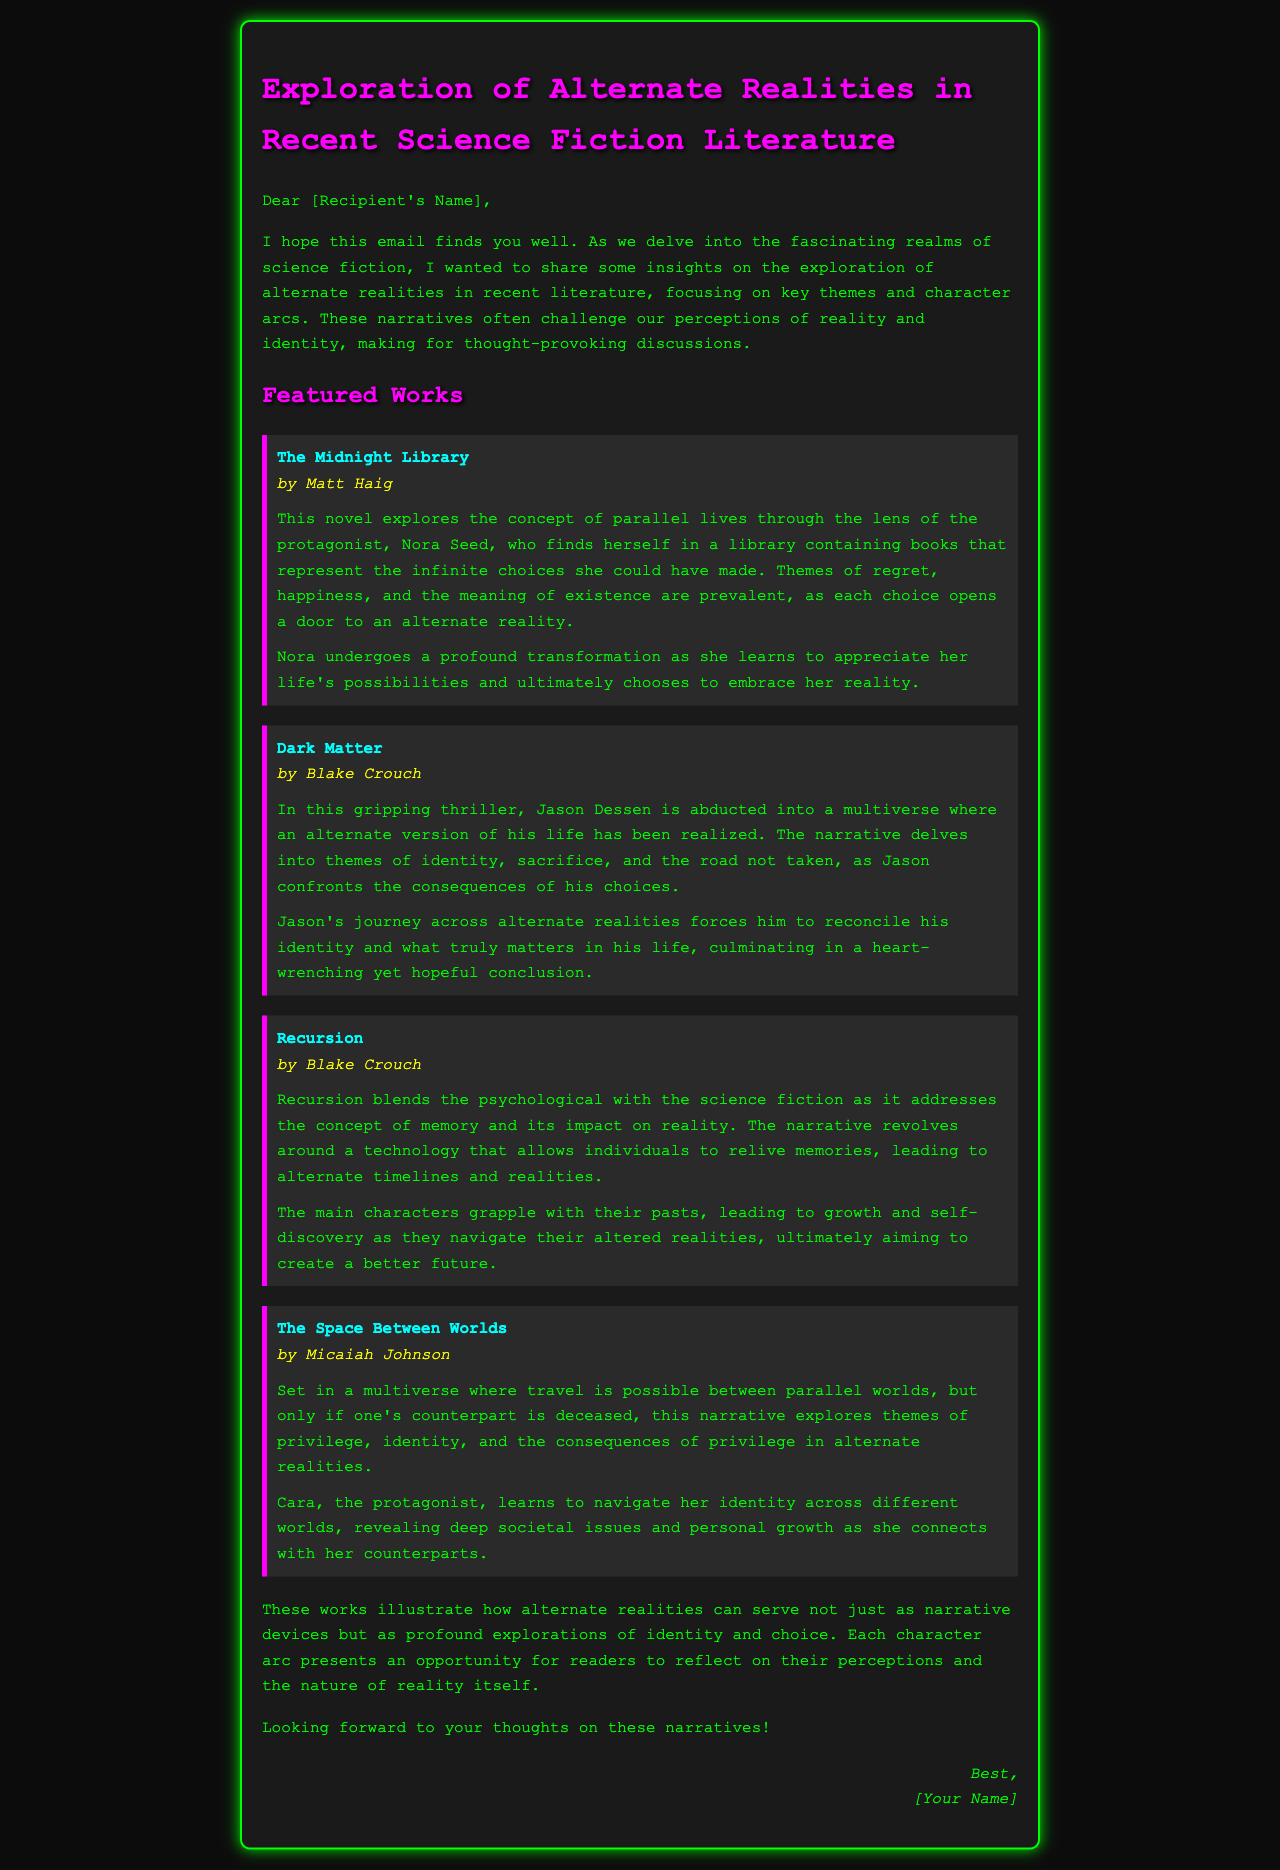What is the title of the first featured work? The title of the first featured work is mentioned at the beginning of the book section.
Answer: The Midnight Library Who is the author of "Dark Matter"? The author of "Dark Matter" is stated directly below the title in the document.
Answer: Blake Crouch What theme is prevalent in "The Midnight Library"? The themes are summarized in the overview of the work, specifically highlighting the concept explored in the narrative.
Answer: Regret, happiness, and the meaning of existence What character undergoes a transformation in "The Midnight Library"? The character's name is described in the character arc section, highlighting their development.
Answer: Nora Seed How many works are discussed in the document? The number of works is determined by counting the individual book sections included in the document.
Answer: Four What does Jason Dessen confront in "Dark Matter"? This is addressed in the summary section, focusing on his challenges within the narrative.
Answer: Consequences of his choices Which book explores themes of privilege and identity? The relevant theme is outlined in the summary of one of the works discussed.
Answer: The Space Between Worlds What transformational journey do the characters in "Recursion" experience? This question relates to the character arc and discusses their struggle throughout the story.
Answer: Growth and self-discovery 